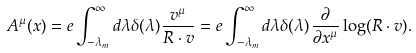Convert formula to latex. <formula><loc_0><loc_0><loc_500><loc_500>A ^ { \mu } ( x ) = e \int _ { - \lambda _ { m } } ^ { \infty } d \lambda \delta ( \lambda ) \frac { v ^ { \mu } } { R \cdot v } = e \int _ { - \lambda _ { m } } ^ { \infty } d \lambda \delta ( \lambda ) \frac { \partial } { \partial x ^ { \mu } } \log ( R \cdot v ) .</formula> 